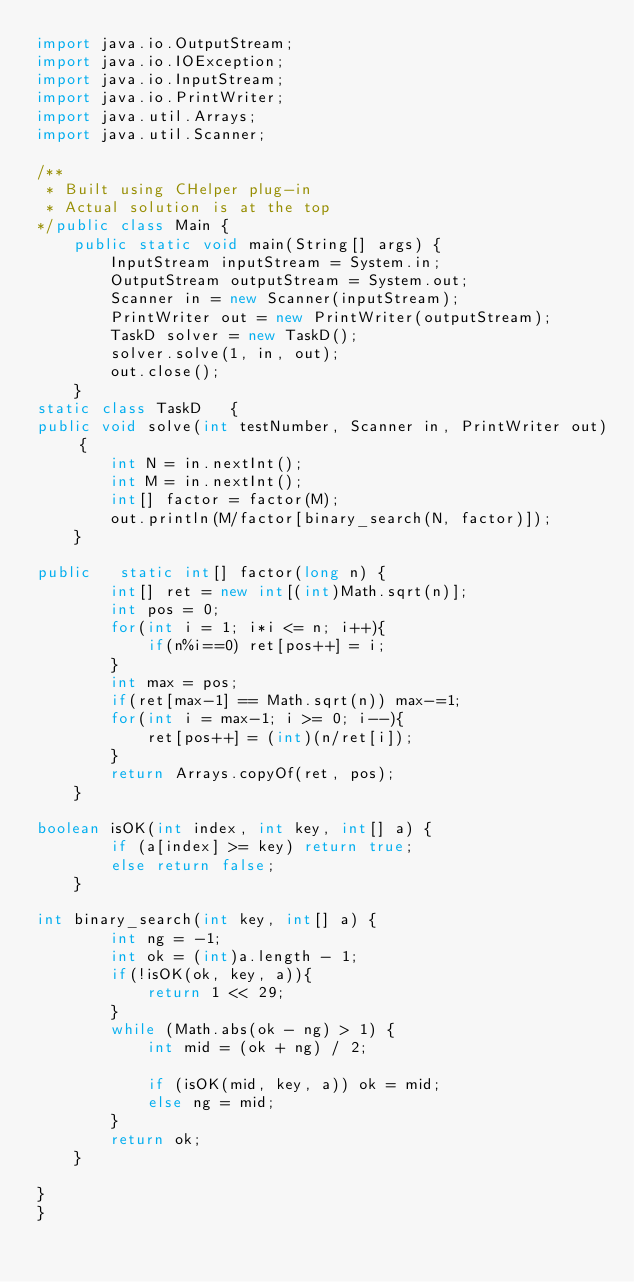<code> <loc_0><loc_0><loc_500><loc_500><_Java_>import java.io.OutputStream;
import java.io.IOException;
import java.io.InputStream;
import java.io.PrintWriter;
import java.util.Arrays;
import java.util.Scanner;

/**
 * Built using CHelper plug-in
 * Actual solution is at the top
*/public class Main {
	public static void main(String[] args) {
		InputStream inputStream = System.in;
		OutputStream outputStream = System.out;
		Scanner in = new Scanner(inputStream);
		PrintWriter out = new PrintWriter(outputStream);
		TaskD solver = new TaskD();
		solver.solve(1, in, out);
		out.close();
	}
static class TaskD   {
public void solve(int testNumber, Scanner in, PrintWriter out) {
        int N = in.nextInt();
        int M = in.nextInt();
        int[] factor = factor(M);
        out.println(M/factor[binary_search(N, factor)]);
    }

public   static int[] factor(long n) {
        int[] ret = new int[(int)Math.sqrt(n)];
        int pos = 0;
        for(int i = 1; i*i <= n; i++){
            if(n%i==0) ret[pos++] = i;
        }
        int max = pos;
        if(ret[max-1] == Math.sqrt(n)) max-=1;
        for(int i = max-1; i >= 0; i--){
            ret[pos++] = (int)(n/ret[i]);
        }
        return Arrays.copyOf(ret, pos);
    }

boolean isOK(int index, int key, int[] a) {
        if (a[index] >= key) return true;
        else return false;
    }

int binary_search(int key, int[] a) {
        int ng = -1;
        int ok = (int)a.length - 1;
        if(!isOK(ok, key, a)){
            return 1 << 29;
        }
        while (Math.abs(ok - ng) > 1) {
            int mid = (ok + ng) / 2;

            if (isOK(mid, key, a)) ok = mid;
            else ng = mid;
        }
        return ok;
    }

}
}

</code> 